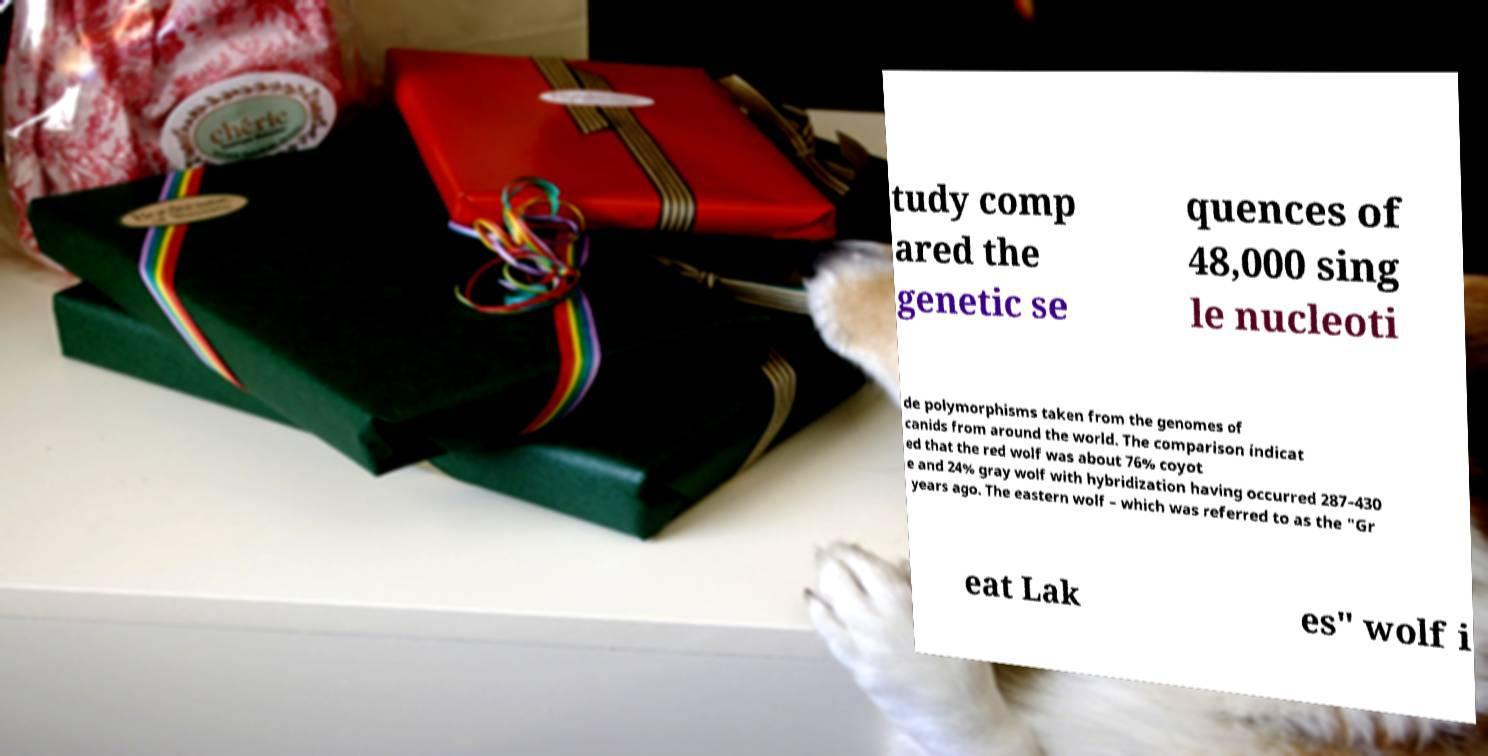Can you read and provide the text displayed in the image?This photo seems to have some interesting text. Can you extract and type it out for me? tudy comp ared the genetic se quences of 48,000 sing le nucleoti de polymorphisms taken from the genomes of canids from around the world. The comparison indicat ed that the red wolf was about 76% coyot e and 24% gray wolf with hybridization having occurred 287–430 years ago. The eastern wolf – which was referred to as the "Gr eat Lak es" wolf i 